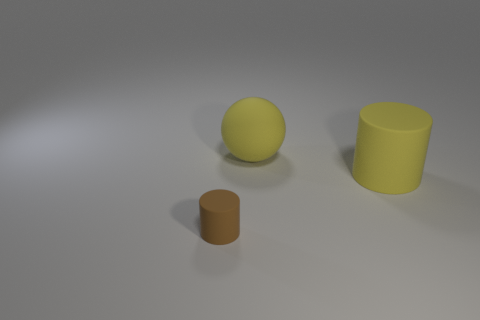Is the number of big objects in front of the brown rubber thing greater than the number of yellow things?
Give a very brief answer. No. There is a thing left of the yellow thing that is on the left side of the big thing in front of the large yellow ball; what is its shape?
Offer a terse response. Cylinder. There is a thing on the right side of the rubber sphere; is it the same size as the small matte thing?
Your answer should be compact. No. What is the shape of the thing that is behind the brown object and in front of the ball?
Offer a terse response. Cylinder. There is a small matte object; does it have the same color as the cylinder behind the brown matte cylinder?
Make the answer very short. No. There is a large object on the right side of the yellow matte thing to the left of the cylinder that is behind the small matte cylinder; what is its color?
Ensure brevity in your answer.  Yellow. There is another rubber object that is the same shape as the small matte thing; what color is it?
Keep it short and to the point. Yellow. Is the number of large yellow matte cylinders that are to the left of the large yellow rubber ball the same as the number of small brown rubber cylinders?
Provide a succinct answer. No. How many cubes are either small brown objects or small purple objects?
Offer a terse response. 0. There is a small cylinder that is made of the same material as the big yellow cylinder; what is its color?
Your answer should be very brief. Brown. 